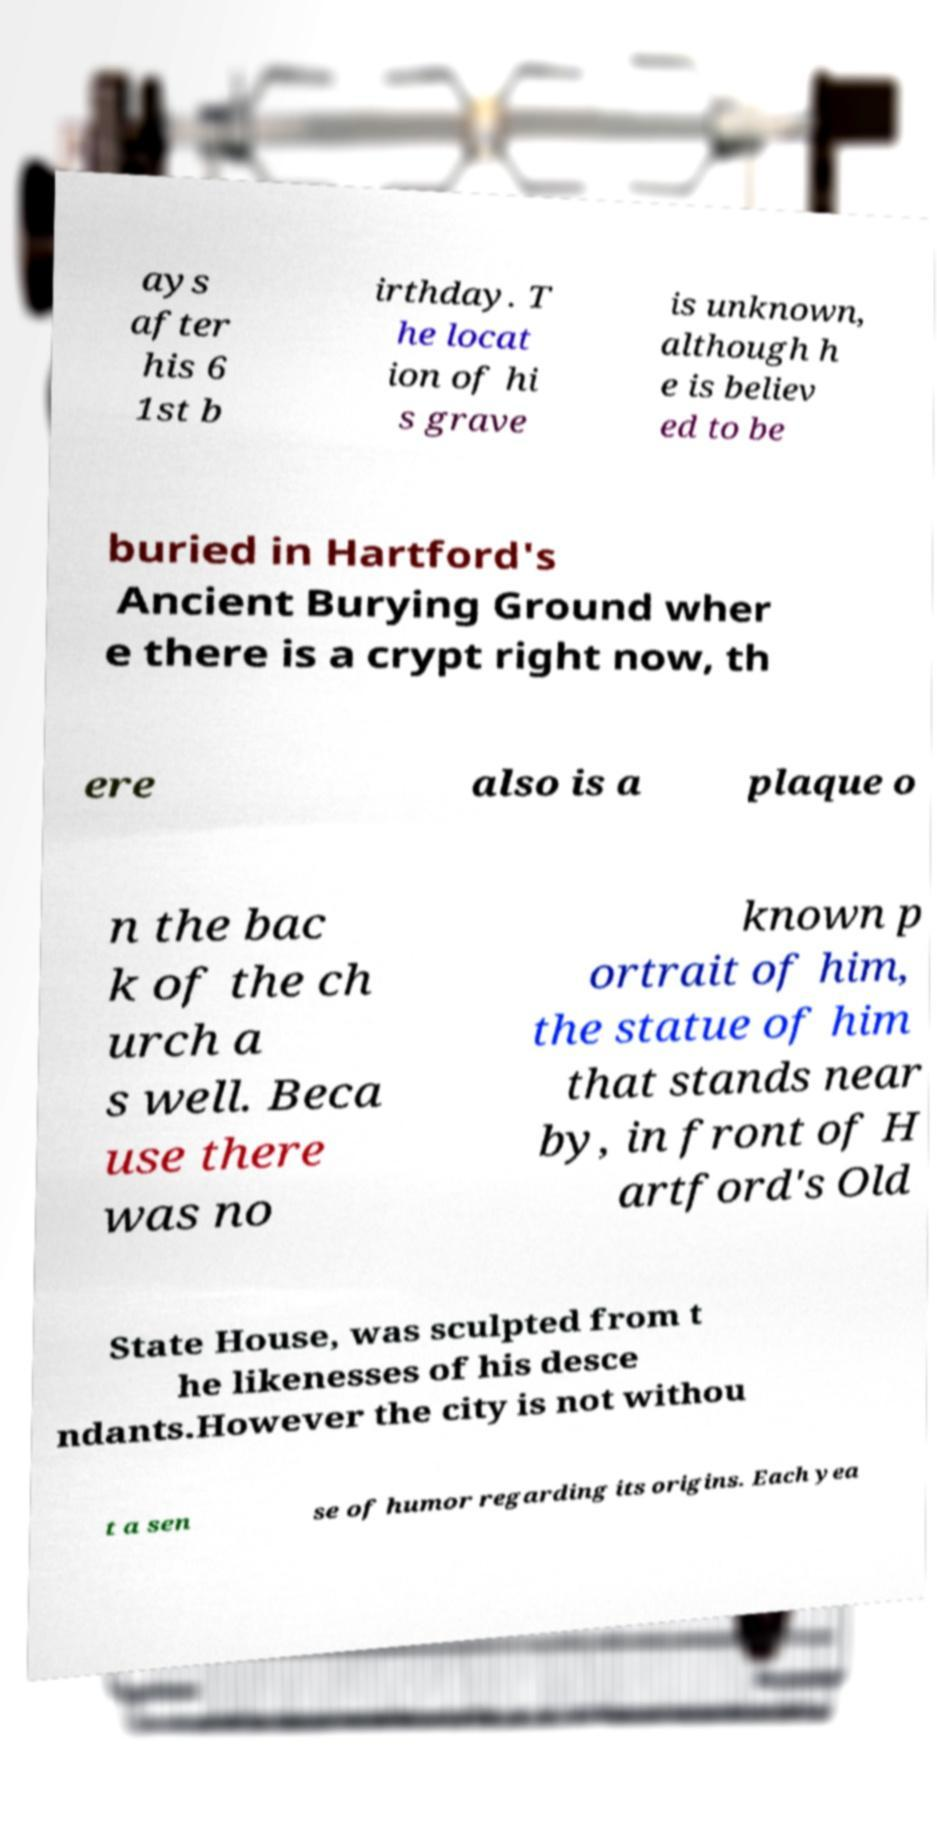What messages or text are displayed in this image? I need them in a readable, typed format. ays after his 6 1st b irthday. T he locat ion of hi s grave is unknown, although h e is believ ed to be buried in Hartford's Ancient Burying Ground wher e there is a crypt right now, th ere also is a plaque o n the bac k of the ch urch a s well. Beca use there was no known p ortrait of him, the statue of him that stands near by, in front of H artford's Old State House, was sculpted from t he likenesses of his desce ndants.However the city is not withou t a sen se of humor regarding its origins. Each yea 